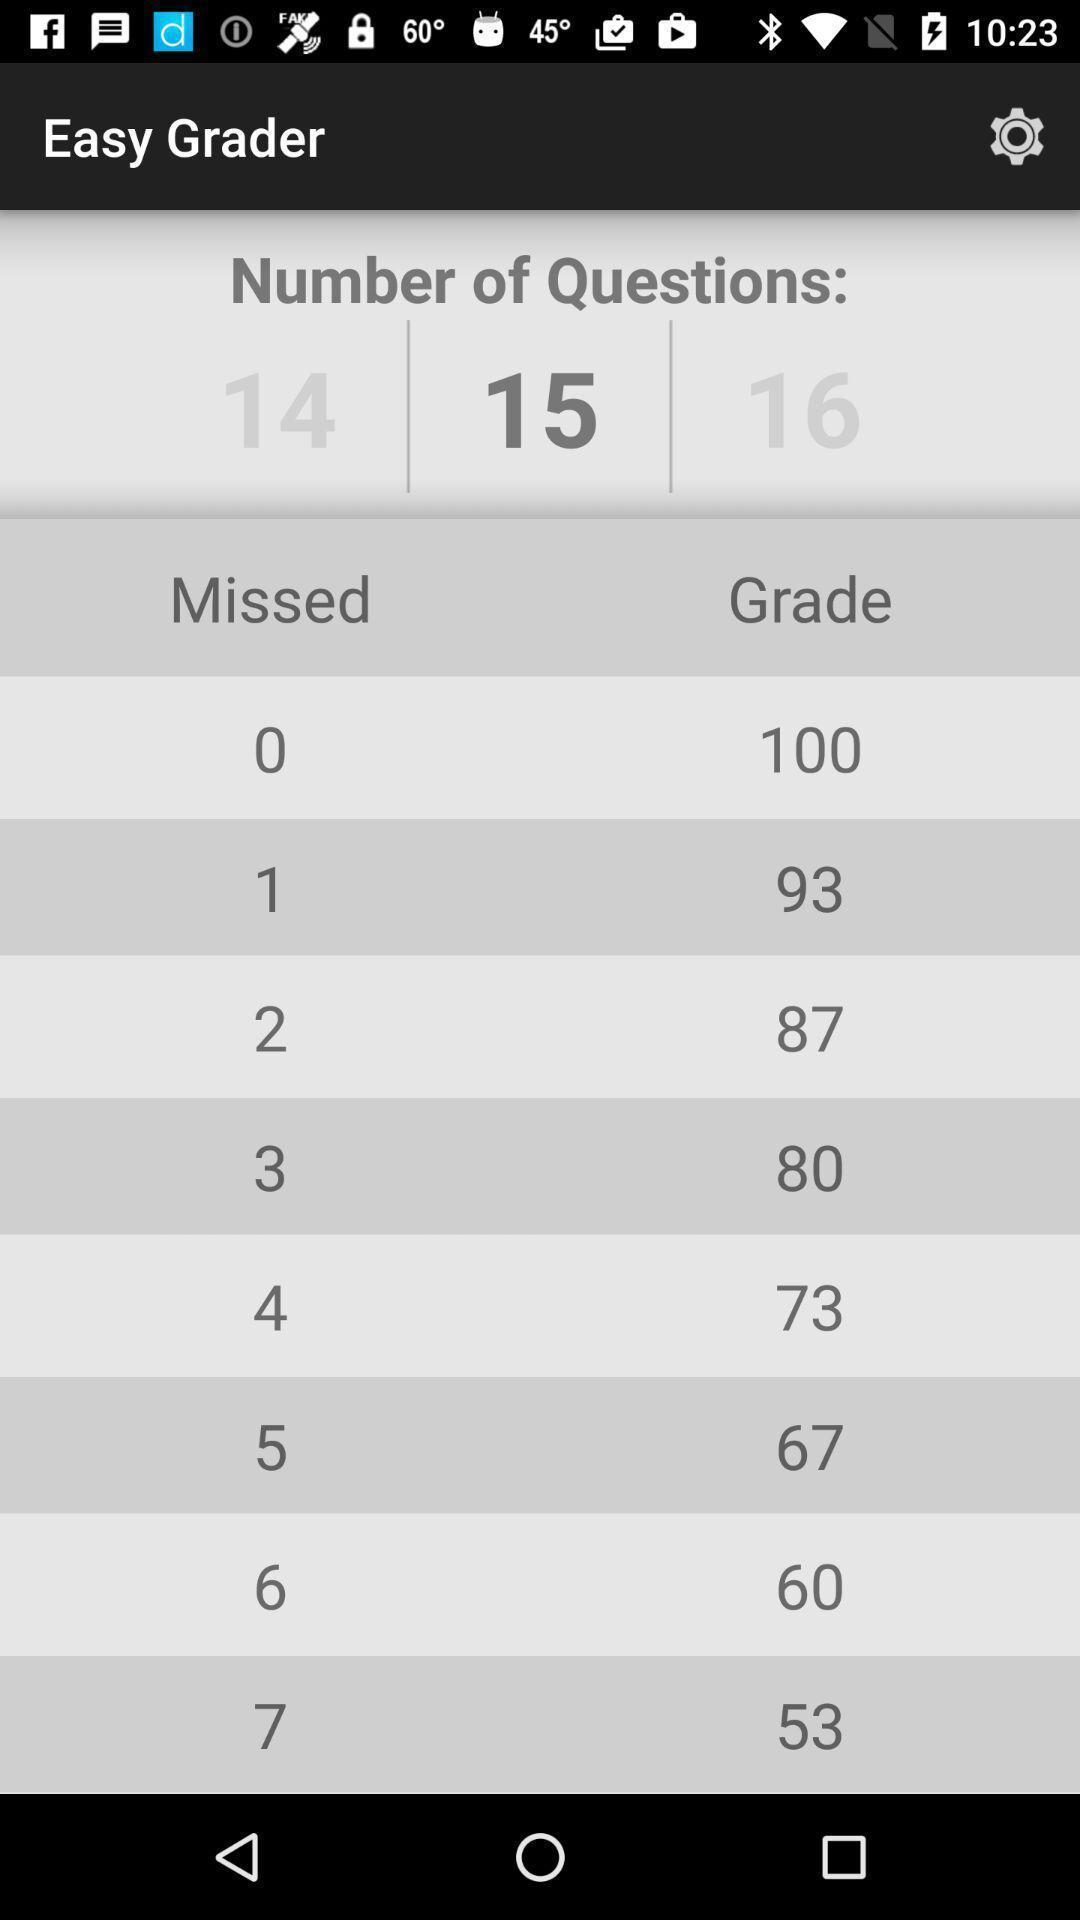Give me a summary of this screen capture. Page showing the score card in learning app. 